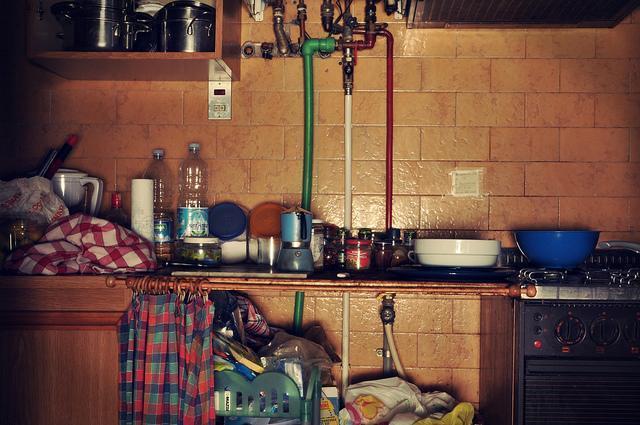When the pipes need to be worked on plumbers will be blocked from reaching it by what?
From the following four choices, select the correct answer to address the question.
Options: Sink, wall, counter, microwave. Counter. 